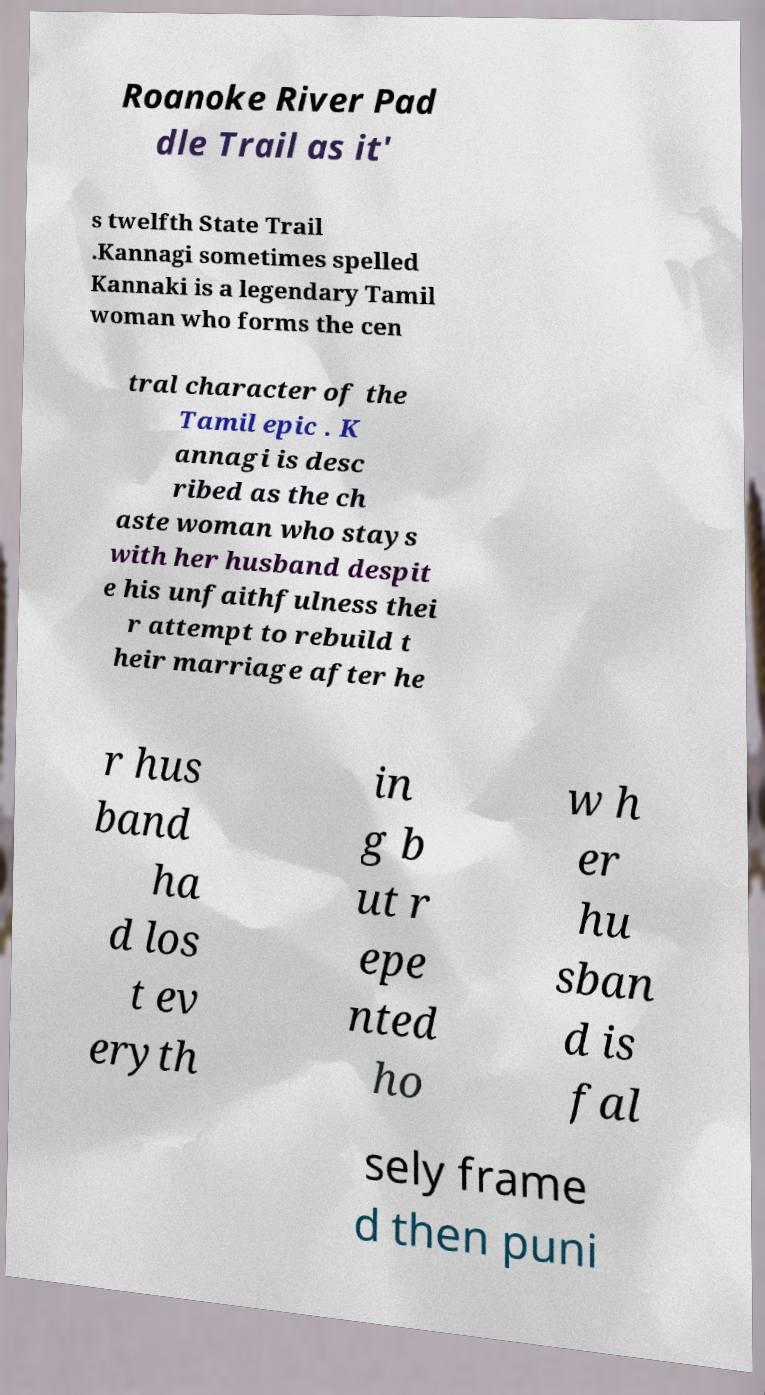There's text embedded in this image that I need extracted. Can you transcribe it verbatim? Roanoke River Pad dle Trail as it' s twelfth State Trail .Kannagi sometimes spelled Kannaki is a legendary Tamil woman who forms the cen tral character of the Tamil epic . K annagi is desc ribed as the ch aste woman who stays with her husband despit e his unfaithfulness thei r attempt to rebuild t heir marriage after he r hus band ha d los t ev eryth in g b ut r epe nted ho w h er hu sban d is fal sely frame d then puni 